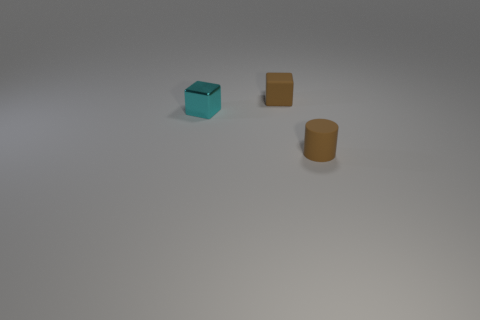Subtract all red cylinders. Subtract all green cubes. How many cylinders are left? 1 Add 3 tiny things. How many objects exist? 6 Subtract all blocks. How many objects are left? 1 Add 1 small cyan metallic blocks. How many small cyan metallic blocks are left? 2 Add 1 tiny yellow rubber objects. How many tiny yellow rubber objects exist? 1 Subtract 0 gray cylinders. How many objects are left? 3 Subtract all tiny cylinders. Subtract all tiny cyan metal cubes. How many objects are left? 1 